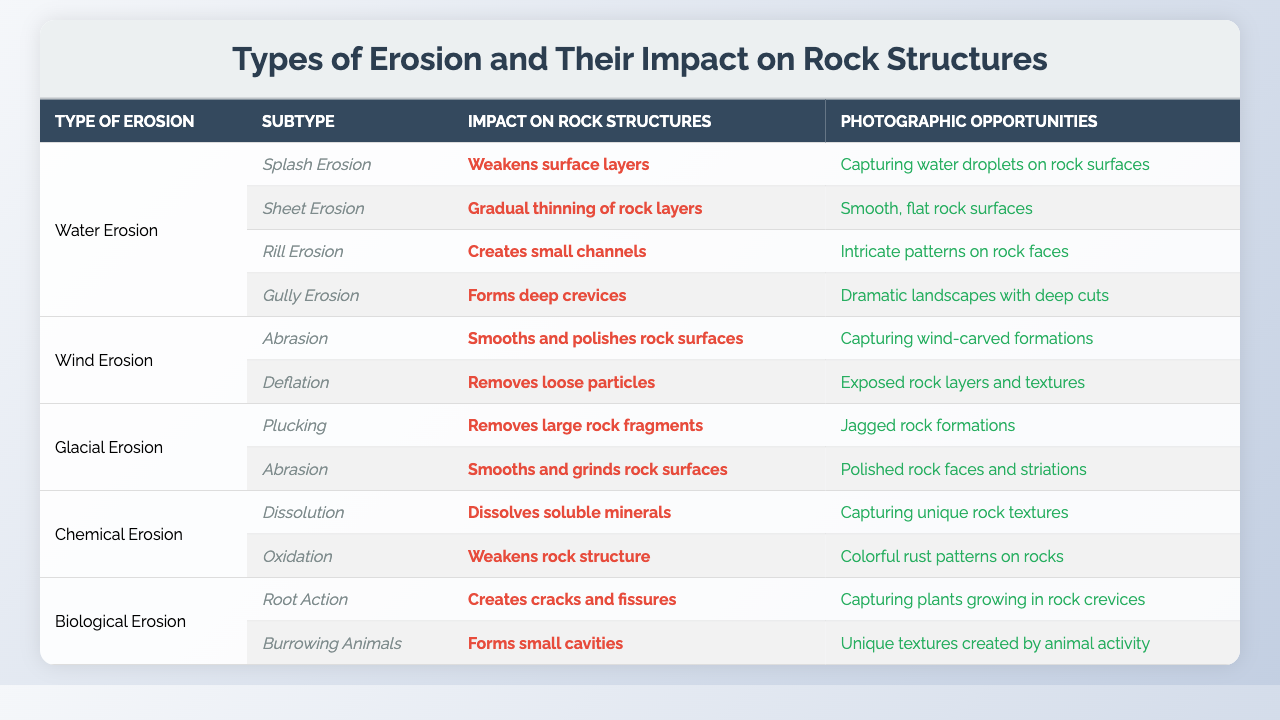What type of erosion creates deep crevices in rock structures? According to the table, Gully Erosion is specified to form deep crevices in rock structures.
Answer: Gully Erosion How many subtypes are listed under Water Erosion? The table indicates that there are four subtypes listed under Water Erosion: Splash Erosion, Sheet Erosion, Rill Erosion, and Gully Erosion.
Answer: Four subtypes Which subtype of Chemical Erosion dissolves soluble minerals? The table states that the Dissolution subtype of Chemical Erosion is responsible for dissolving soluble minerals.
Answer: Dissolution What impact does Wind Erosion have on rock surfaces? The table shows that Wind Erosion can smooth and polish rock surfaces, particularly through its type Abrasion.
Answer: Smooths and polishes Are there any types of erosion that have the same impact on rock structures? Yes, both Abrasion under Wind Erosion and Abrasion under Glacial Erosion smooth and grind rock surfaces, indicating a similar impact on rock structures.
Answer: Yes How many photographic opportunities are associated with Biological Erosion types? The table lists two types of Biological Erosion: Root Action and Burrowing Animals, each having a photographic opportunity associated with them. Therefore, there are two photographic opportunities.
Answer: Two opportunities What is the unique photographic opportunity for Rill Erosion? The table states that Rill Erosion provides the opportunity to capture intricate patterns on rock faces.
Answer: Intricate patterns on rock faces Which type of erosion has the most subtypes listed? By examining the table data, Water Erosion has the most subtypes listed with four subtypes compared to the others that have less.
Answer: Water Erosion What are the impacts of Oxidation on rock structures? The table mentions that Oxidation weakens the rock structure, indicating it has a detrimental impact.
Answer: Weakens rock structure Can you list all the impacts of Chemical Erosion? The impacts of Chemical Erosion listed in the table include the dissolution of soluble minerals (Dissolution) and the weakening of the rock structure (Oxidation).
Answer: Dissolution and weakening of rock structure 